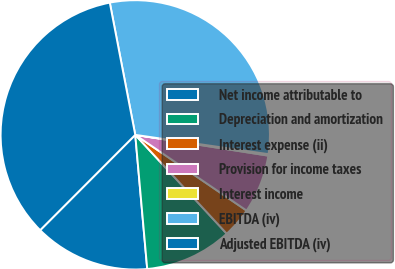<chart> <loc_0><loc_0><loc_500><loc_500><pie_chart><fcel>Net income attributable to<fcel>Depreciation and amortization<fcel>Interest expense (ii)<fcel>Provision for income taxes<fcel>Interest income<fcel>EBITDA (iv)<fcel>Adjusted EBITDA (iv)<nl><fcel>13.9%<fcel>10.47%<fcel>3.61%<fcel>7.04%<fcel>0.18%<fcel>30.32%<fcel>34.49%<nl></chart> 